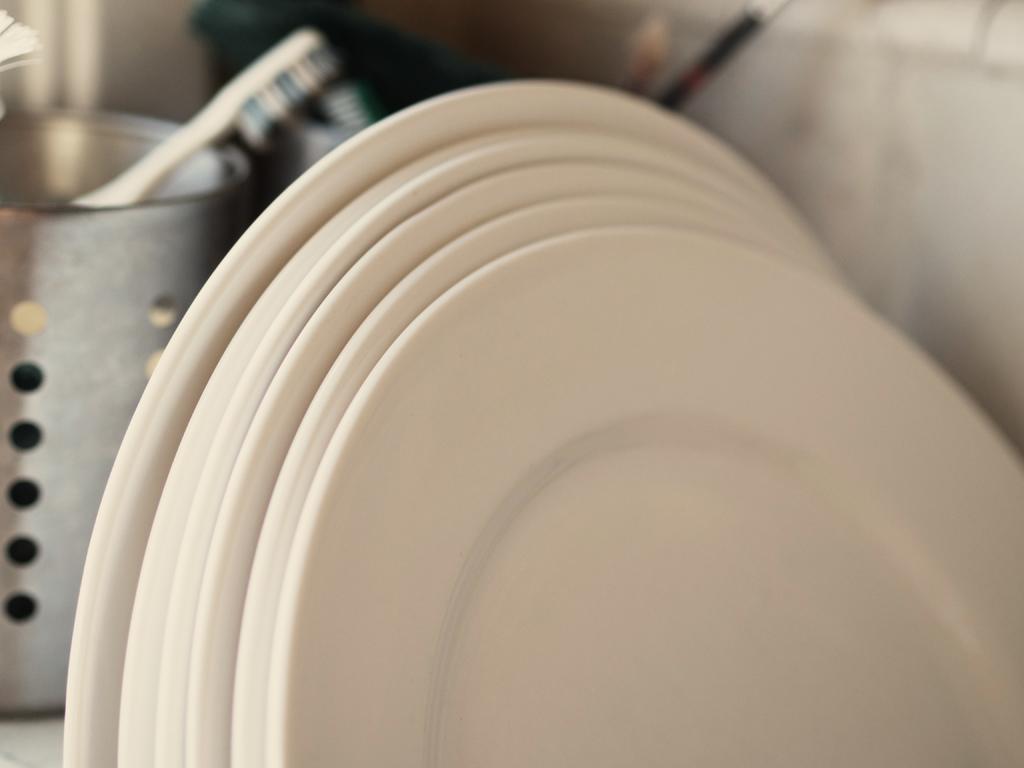In one or two sentences, can you explain what this image depicts? In this image in the foreground there are some plates and in the background there is one box, in the box there is one brush and also there are some objects. 